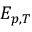<formula> <loc_0><loc_0><loc_500><loc_500>E _ { p , T }</formula> 